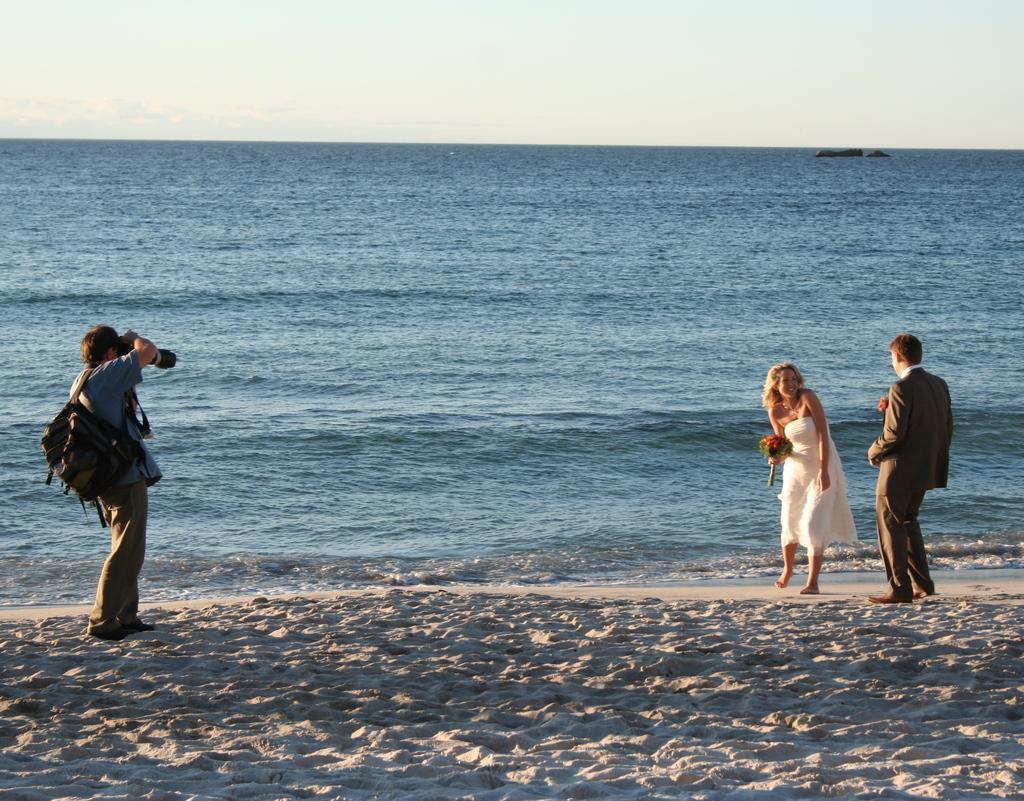In one or two sentences, can you explain what this image depicts? On the left there is a man standing on the sand and carrying a bag on his shoulder and capturing a man and woman who are standing on the sand on the right side. In the background there is water and sky. On the right there is an object on the water. 